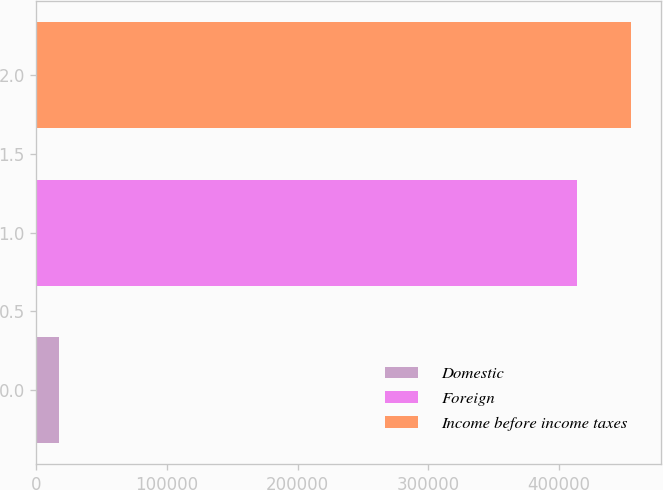<chart> <loc_0><loc_0><loc_500><loc_500><bar_chart><fcel>Domestic<fcel>Foreign<fcel>Income before income taxes<nl><fcel>17215<fcel>413931<fcel>455324<nl></chart> 